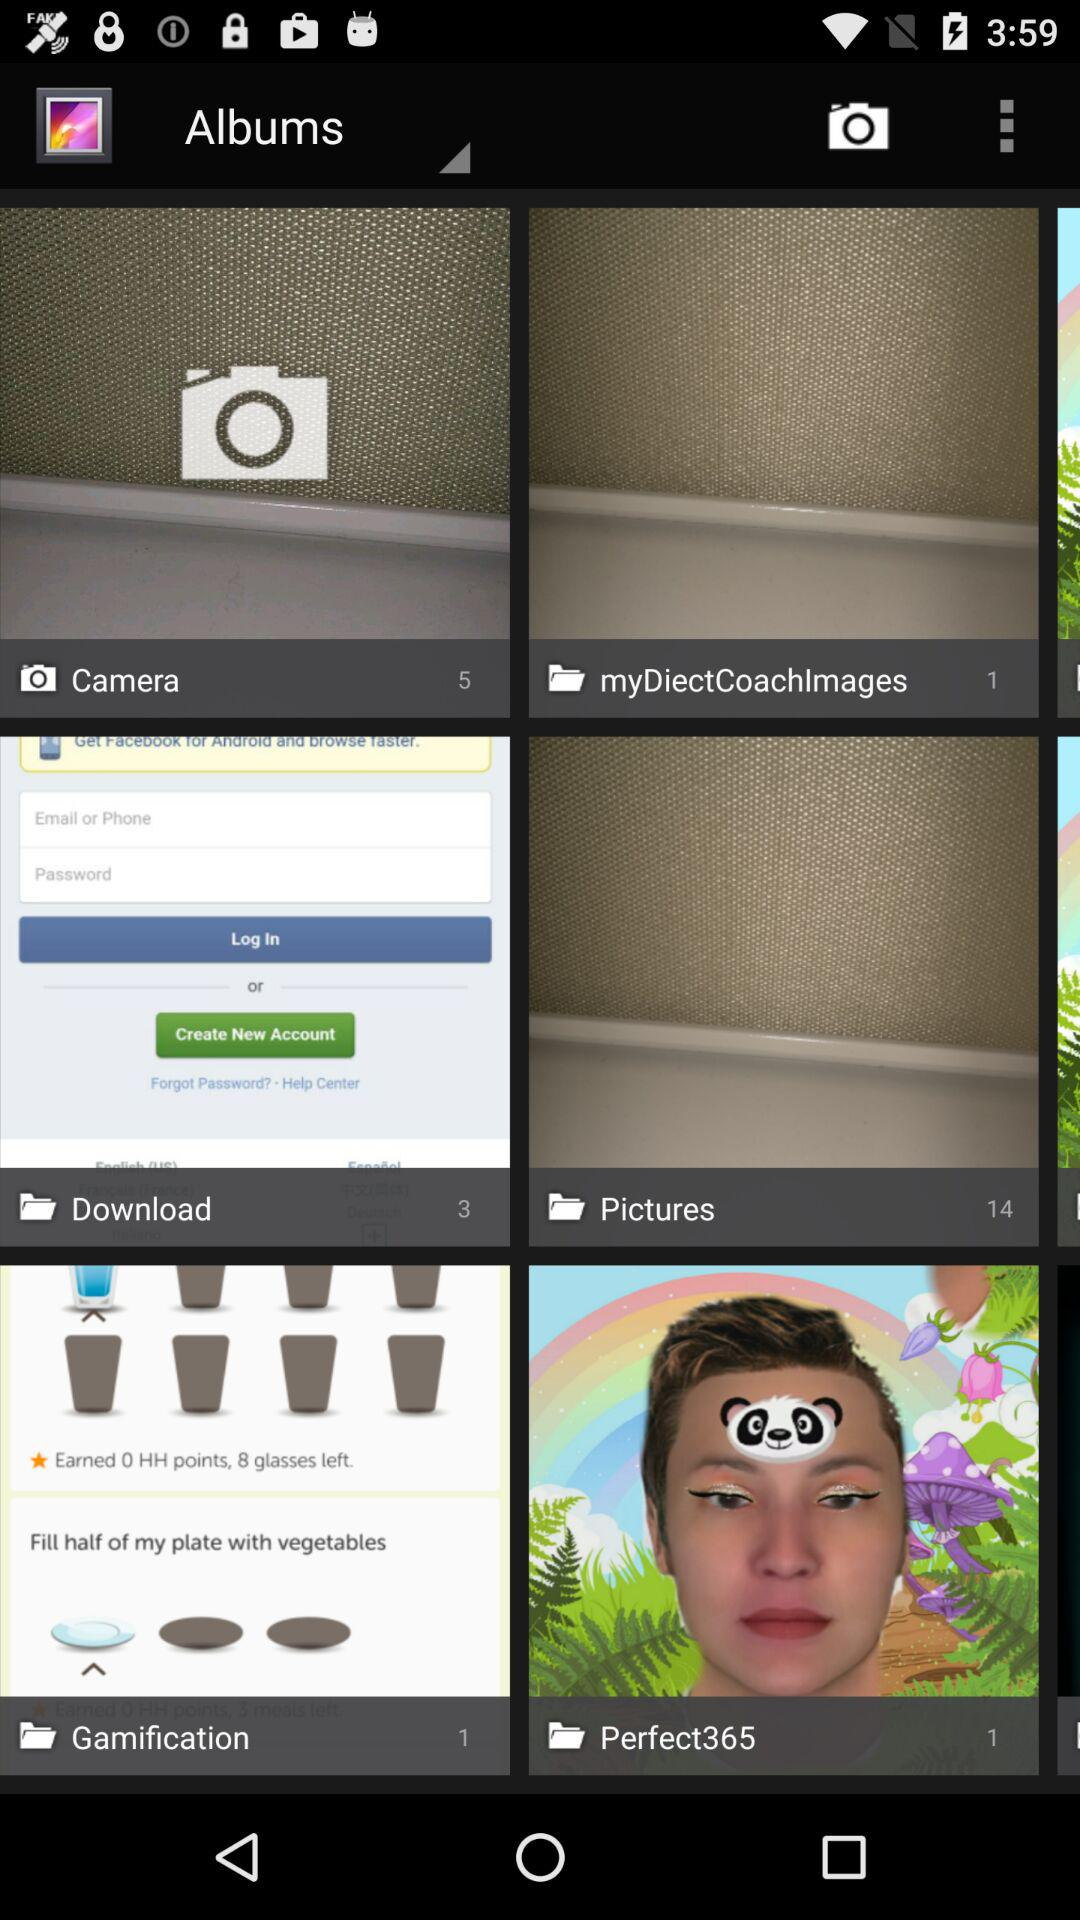What is the count of photos in the "Perfect365" folder? The count of photos is 1. 